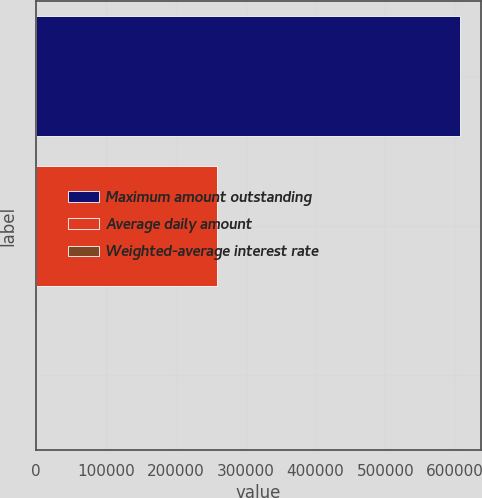Convert chart to OTSL. <chart><loc_0><loc_0><loc_500><loc_500><bar_chart><fcel>Maximum amount outstanding<fcel>Average daily amount<fcel>Weighted-average interest rate<nl><fcel>606753<fcel>258815<fcel>1.79<nl></chart> 